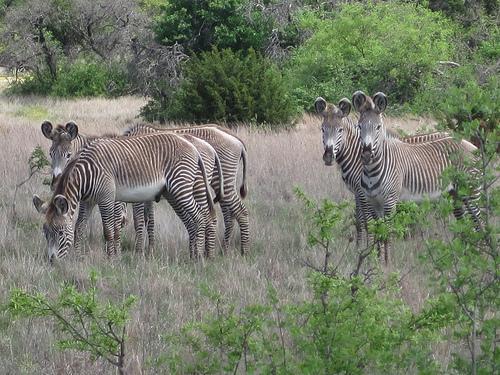How many animals are in the image?
Give a very brief answer. 5. How many legs do the zebras have?
Give a very brief answer. 4. 